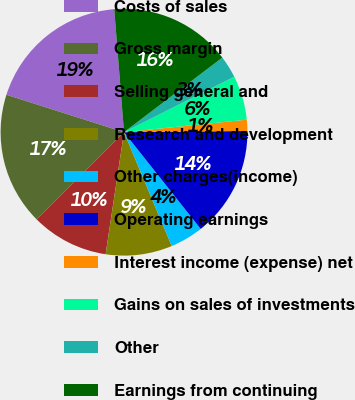Convert chart. <chart><loc_0><loc_0><loc_500><loc_500><pie_chart><fcel>Costs of sales<fcel>Gross margin<fcel>Selling general and<fcel>Research and development<fcel>Other charges(income)<fcel>Operating earnings<fcel>Interest income (expense) net<fcel>Gains on sales of investments<fcel>Other<fcel>Earnings from continuing<nl><fcel>18.83%<fcel>17.38%<fcel>10.14%<fcel>8.7%<fcel>4.35%<fcel>14.49%<fcel>1.46%<fcel>5.8%<fcel>2.91%<fcel>15.93%<nl></chart> 